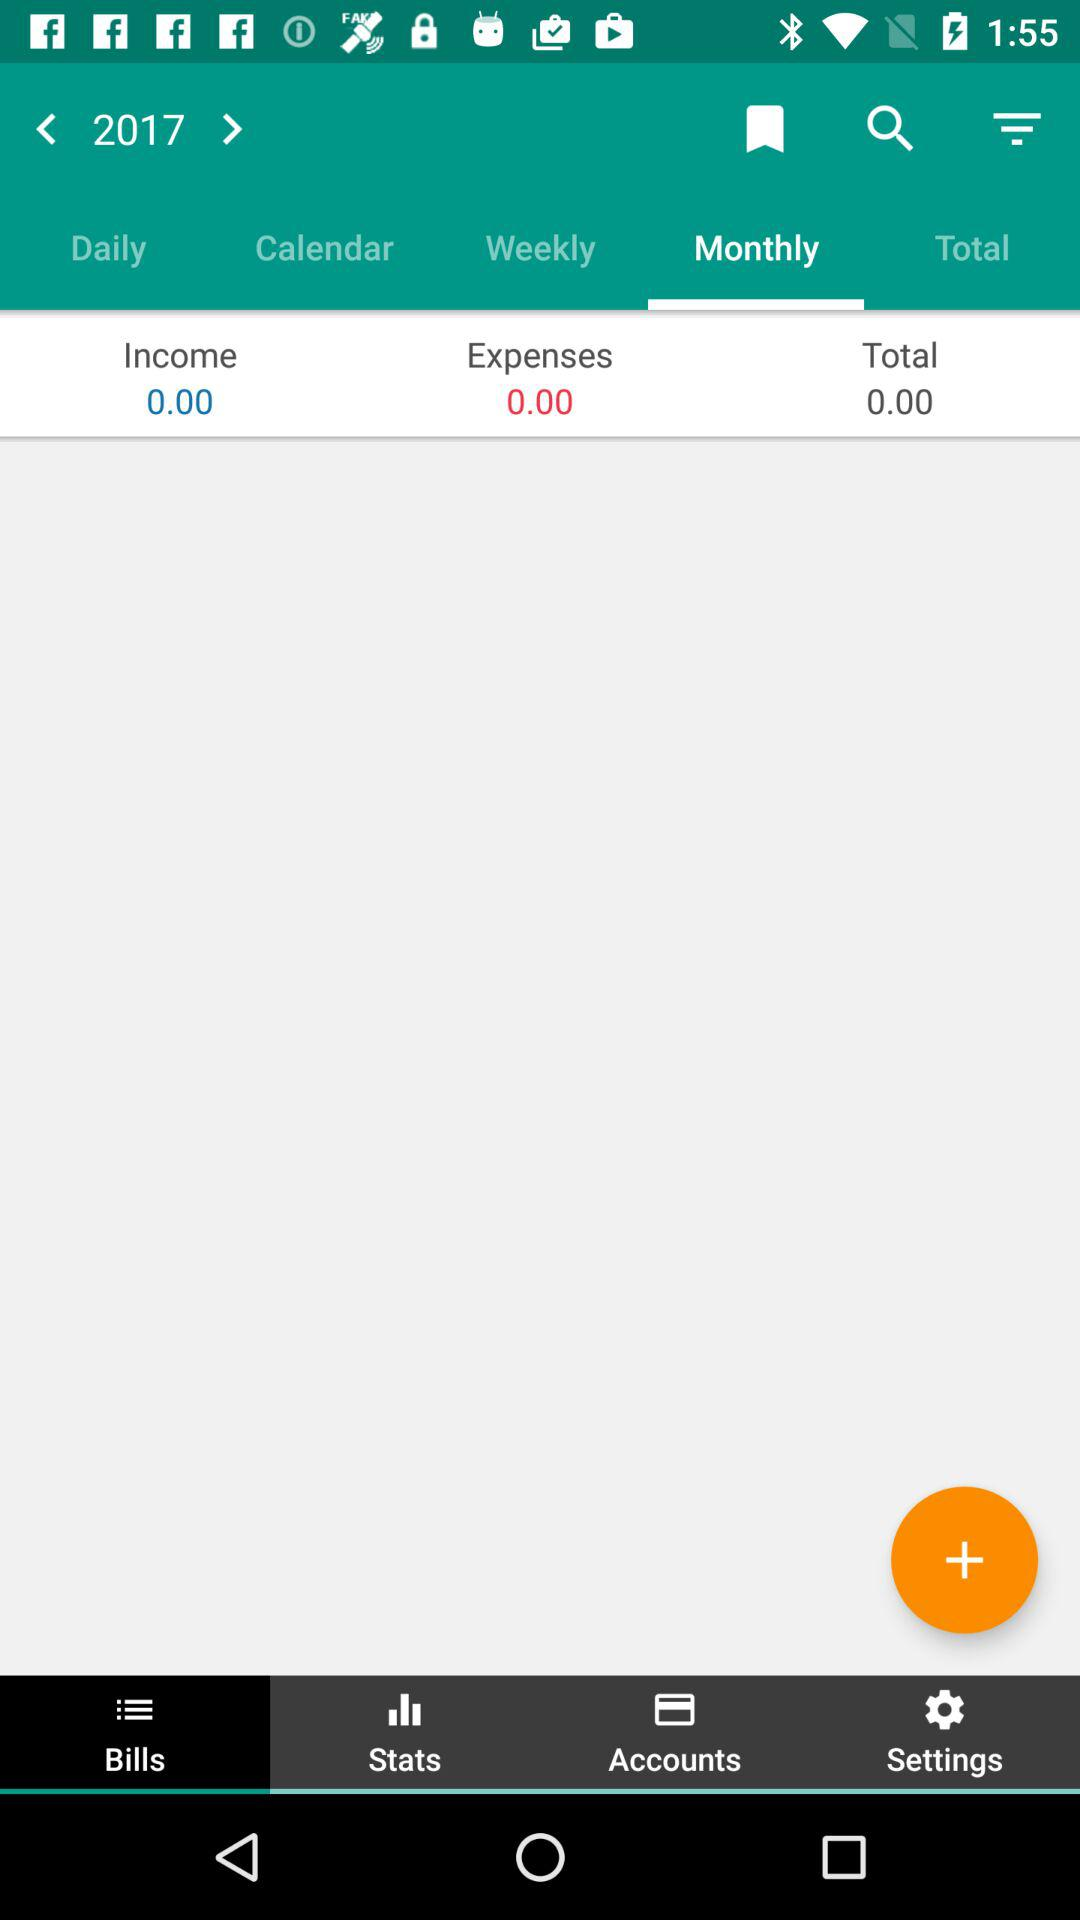What is the "Income" amount? The "Income" amount is 0. 